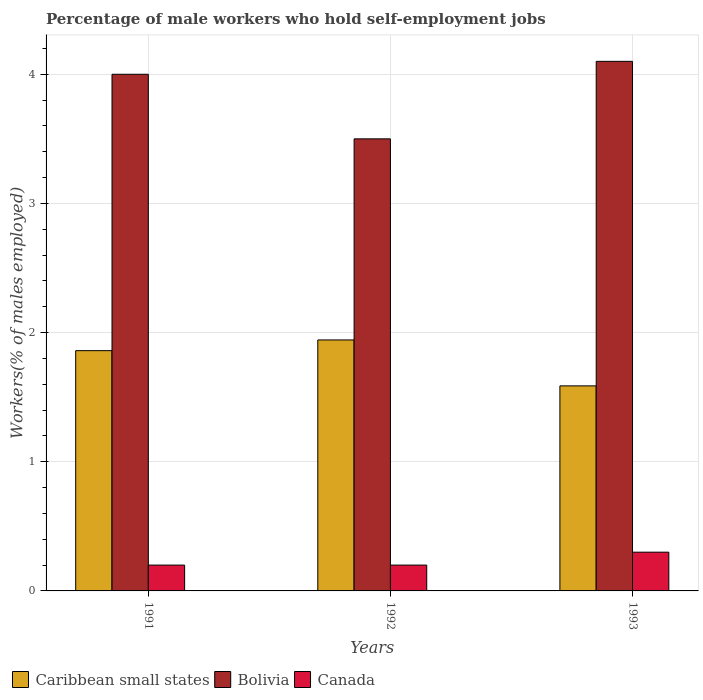How many groups of bars are there?
Your response must be concise. 3. How many bars are there on the 1st tick from the left?
Make the answer very short. 3. In how many cases, is the number of bars for a given year not equal to the number of legend labels?
Your answer should be very brief. 0. What is the percentage of self-employed male workers in Canada in 1993?
Your answer should be very brief. 0.3. Across all years, what is the maximum percentage of self-employed male workers in Caribbean small states?
Provide a short and direct response. 1.94. Across all years, what is the minimum percentage of self-employed male workers in Canada?
Make the answer very short. 0.2. In which year was the percentage of self-employed male workers in Canada maximum?
Offer a very short reply. 1993. In which year was the percentage of self-employed male workers in Caribbean small states minimum?
Ensure brevity in your answer.  1993. What is the total percentage of self-employed male workers in Canada in the graph?
Keep it short and to the point. 0.7. What is the difference between the percentage of self-employed male workers in Bolivia in 1992 and that in 1993?
Provide a succinct answer. -0.6. What is the difference between the percentage of self-employed male workers in Bolivia in 1992 and the percentage of self-employed male workers in Caribbean small states in 1993?
Make the answer very short. 1.91. What is the average percentage of self-employed male workers in Canada per year?
Give a very brief answer. 0.23. In the year 1991, what is the difference between the percentage of self-employed male workers in Bolivia and percentage of self-employed male workers in Caribbean small states?
Provide a short and direct response. 2.14. What is the ratio of the percentage of self-employed male workers in Caribbean small states in 1991 to that in 1992?
Ensure brevity in your answer.  0.96. What is the difference between the highest and the second highest percentage of self-employed male workers in Caribbean small states?
Provide a short and direct response. 0.08. What is the difference between the highest and the lowest percentage of self-employed male workers in Canada?
Ensure brevity in your answer.  0.1. What does the 1st bar from the left in 1992 represents?
Ensure brevity in your answer.  Caribbean small states. What does the 2nd bar from the right in 1993 represents?
Make the answer very short. Bolivia. How many bars are there?
Provide a short and direct response. 9. How many years are there in the graph?
Make the answer very short. 3. Does the graph contain grids?
Offer a very short reply. Yes. How are the legend labels stacked?
Make the answer very short. Horizontal. What is the title of the graph?
Your answer should be compact. Percentage of male workers who hold self-employment jobs. What is the label or title of the Y-axis?
Keep it short and to the point. Workers(% of males employed). What is the Workers(% of males employed) in Caribbean small states in 1991?
Make the answer very short. 1.86. What is the Workers(% of males employed) in Canada in 1991?
Your answer should be compact. 0.2. What is the Workers(% of males employed) in Caribbean small states in 1992?
Provide a short and direct response. 1.94. What is the Workers(% of males employed) in Bolivia in 1992?
Offer a very short reply. 3.5. What is the Workers(% of males employed) in Canada in 1992?
Offer a very short reply. 0.2. What is the Workers(% of males employed) of Caribbean small states in 1993?
Your response must be concise. 1.59. What is the Workers(% of males employed) in Bolivia in 1993?
Ensure brevity in your answer.  4.1. What is the Workers(% of males employed) of Canada in 1993?
Provide a succinct answer. 0.3. Across all years, what is the maximum Workers(% of males employed) of Caribbean small states?
Provide a short and direct response. 1.94. Across all years, what is the maximum Workers(% of males employed) of Bolivia?
Make the answer very short. 4.1. Across all years, what is the maximum Workers(% of males employed) of Canada?
Make the answer very short. 0.3. Across all years, what is the minimum Workers(% of males employed) of Caribbean small states?
Give a very brief answer. 1.59. Across all years, what is the minimum Workers(% of males employed) of Bolivia?
Give a very brief answer. 3.5. Across all years, what is the minimum Workers(% of males employed) of Canada?
Your answer should be compact. 0.2. What is the total Workers(% of males employed) of Caribbean small states in the graph?
Make the answer very short. 5.39. What is the total Workers(% of males employed) of Bolivia in the graph?
Offer a very short reply. 11.6. What is the difference between the Workers(% of males employed) in Caribbean small states in 1991 and that in 1992?
Provide a succinct answer. -0.08. What is the difference between the Workers(% of males employed) in Canada in 1991 and that in 1992?
Keep it short and to the point. 0. What is the difference between the Workers(% of males employed) of Caribbean small states in 1991 and that in 1993?
Provide a succinct answer. 0.27. What is the difference between the Workers(% of males employed) in Bolivia in 1991 and that in 1993?
Provide a succinct answer. -0.1. What is the difference between the Workers(% of males employed) in Caribbean small states in 1992 and that in 1993?
Give a very brief answer. 0.36. What is the difference between the Workers(% of males employed) in Bolivia in 1992 and that in 1993?
Give a very brief answer. -0.6. What is the difference between the Workers(% of males employed) of Caribbean small states in 1991 and the Workers(% of males employed) of Bolivia in 1992?
Your answer should be compact. -1.64. What is the difference between the Workers(% of males employed) in Caribbean small states in 1991 and the Workers(% of males employed) in Canada in 1992?
Provide a short and direct response. 1.66. What is the difference between the Workers(% of males employed) of Caribbean small states in 1991 and the Workers(% of males employed) of Bolivia in 1993?
Provide a short and direct response. -2.24. What is the difference between the Workers(% of males employed) of Caribbean small states in 1991 and the Workers(% of males employed) of Canada in 1993?
Give a very brief answer. 1.56. What is the difference between the Workers(% of males employed) of Bolivia in 1991 and the Workers(% of males employed) of Canada in 1993?
Your answer should be very brief. 3.7. What is the difference between the Workers(% of males employed) in Caribbean small states in 1992 and the Workers(% of males employed) in Bolivia in 1993?
Your answer should be very brief. -2.16. What is the difference between the Workers(% of males employed) of Caribbean small states in 1992 and the Workers(% of males employed) of Canada in 1993?
Offer a very short reply. 1.64. What is the average Workers(% of males employed) in Caribbean small states per year?
Provide a short and direct response. 1.8. What is the average Workers(% of males employed) of Bolivia per year?
Make the answer very short. 3.87. What is the average Workers(% of males employed) of Canada per year?
Your answer should be very brief. 0.23. In the year 1991, what is the difference between the Workers(% of males employed) of Caribbean small states and Workers(% of males employed) of Bolivia?
Keep it short and to the point. -2.14. In the year 1991, what is the difference between the Workers(% of males employed) of Caribbean small states and Workers(% of males employed) of Canada?
Keep it short and to the point. 1.66. In the year 1992, what is the difference between the Workers(% of males employed) of Caribbean small states and Workers(% of males employed) of Bolivia?
Provide a succinct answer. -1.56. In the year 1992, what is the difference between the Workers(% of males employed) in Caribbean small states and Workers(% of males employed) in Canada?
Offer a terse response. 1.74. In the year 1992, what is the difference between the Workers(% of males employed) in Bolivia and Workers(% of males employed) in Canada?
Offer a very short reply. 3.3. In the year 1993, what is the difference between the Workers(% of males employed) in Caribbean small states and Workers(% of males employed) in Bolivia?
Make the answer very short. -2.51. In the year 1993, what is the difference between the Workers(% of males employed) of Caribbean small states and Workers(% of males employed) of Canada?
Offer a terse response. 1.29. What is the ratio of the Workers(% of males employed) of Caribbean small states in 1991 to that in 1992?
Offer a terse response. 0.96. What is the ratio of the Workers(% of males employed) of Bolivia in 1991 to that in 1992?
Your answer should be very brief. 1.14. What is the ratio of the Workers(% of males employed) of Caribbean small states in 1991 to that in 1993?
Keep it short and to the point. 1.17. What is the ratio of the Workers(% of males employed) in Bolivia in 1991 to that in 1993?
Make the answer very short. 0.98. What is the ratio of the Workers(% of males employed) in Caribbean small states in 1992 to that in 1993?
Offer a terse response. 1.22. What is the ratio of the Workers(% of males employed) of Bolivia in 1992 to that in 1993?
Keep it short and to the point. 0.85. What is the difference between the highest and the second highest Workers(% of males employed) of Caribbean small states?
Your answer should be very brief. 0.08. What is the difference between the highest and the second highest Workers(% of males employed) in Canada?
Keep it short and to the point. 0.1. What is the difference between the highest and the lowest Workers(% of males employed) in Caribbean small states?
Keep it short and to the point. 0.36. What is the difference between the highest and the lowest Workers(% of males employed) of Bolivia?
Your answer should be very brief. 0.6. What is the difference between the highest and the lowest Workers(% of males employed) in Canada?
Make the answer very short. 0.1. 